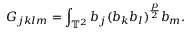<formula> <loc_0><loc_0><loc_500><loc_500>G _ { j k l m } = \int _ { \mathbb { T } ^ { 2 } } b _ { j } ( b _ { k } b _ { l } ) ^ { \frac { p } { 2 } } b _ { m } .</formula> 